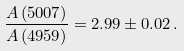Convert formula to latex. <formula><loc_0><loc_0><loc_500><loc_500>\frac { A \left ( 5 0 0 7 \right ) } { A \left ( 4 9 5 9 \right ) } = 2 . 9 9 \pm 0 . 0 2 \, .</formula> 